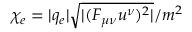Convert formula to latex. <formula><loc_0><loc_0><loc_500><loc_500>\chi _ { e } = | q _ { e } | \sqrt { | ( F _ { \mu \nu } u ^ { \nu } ) ^ { 2 } | } / m ^ { 2 }</formula> 